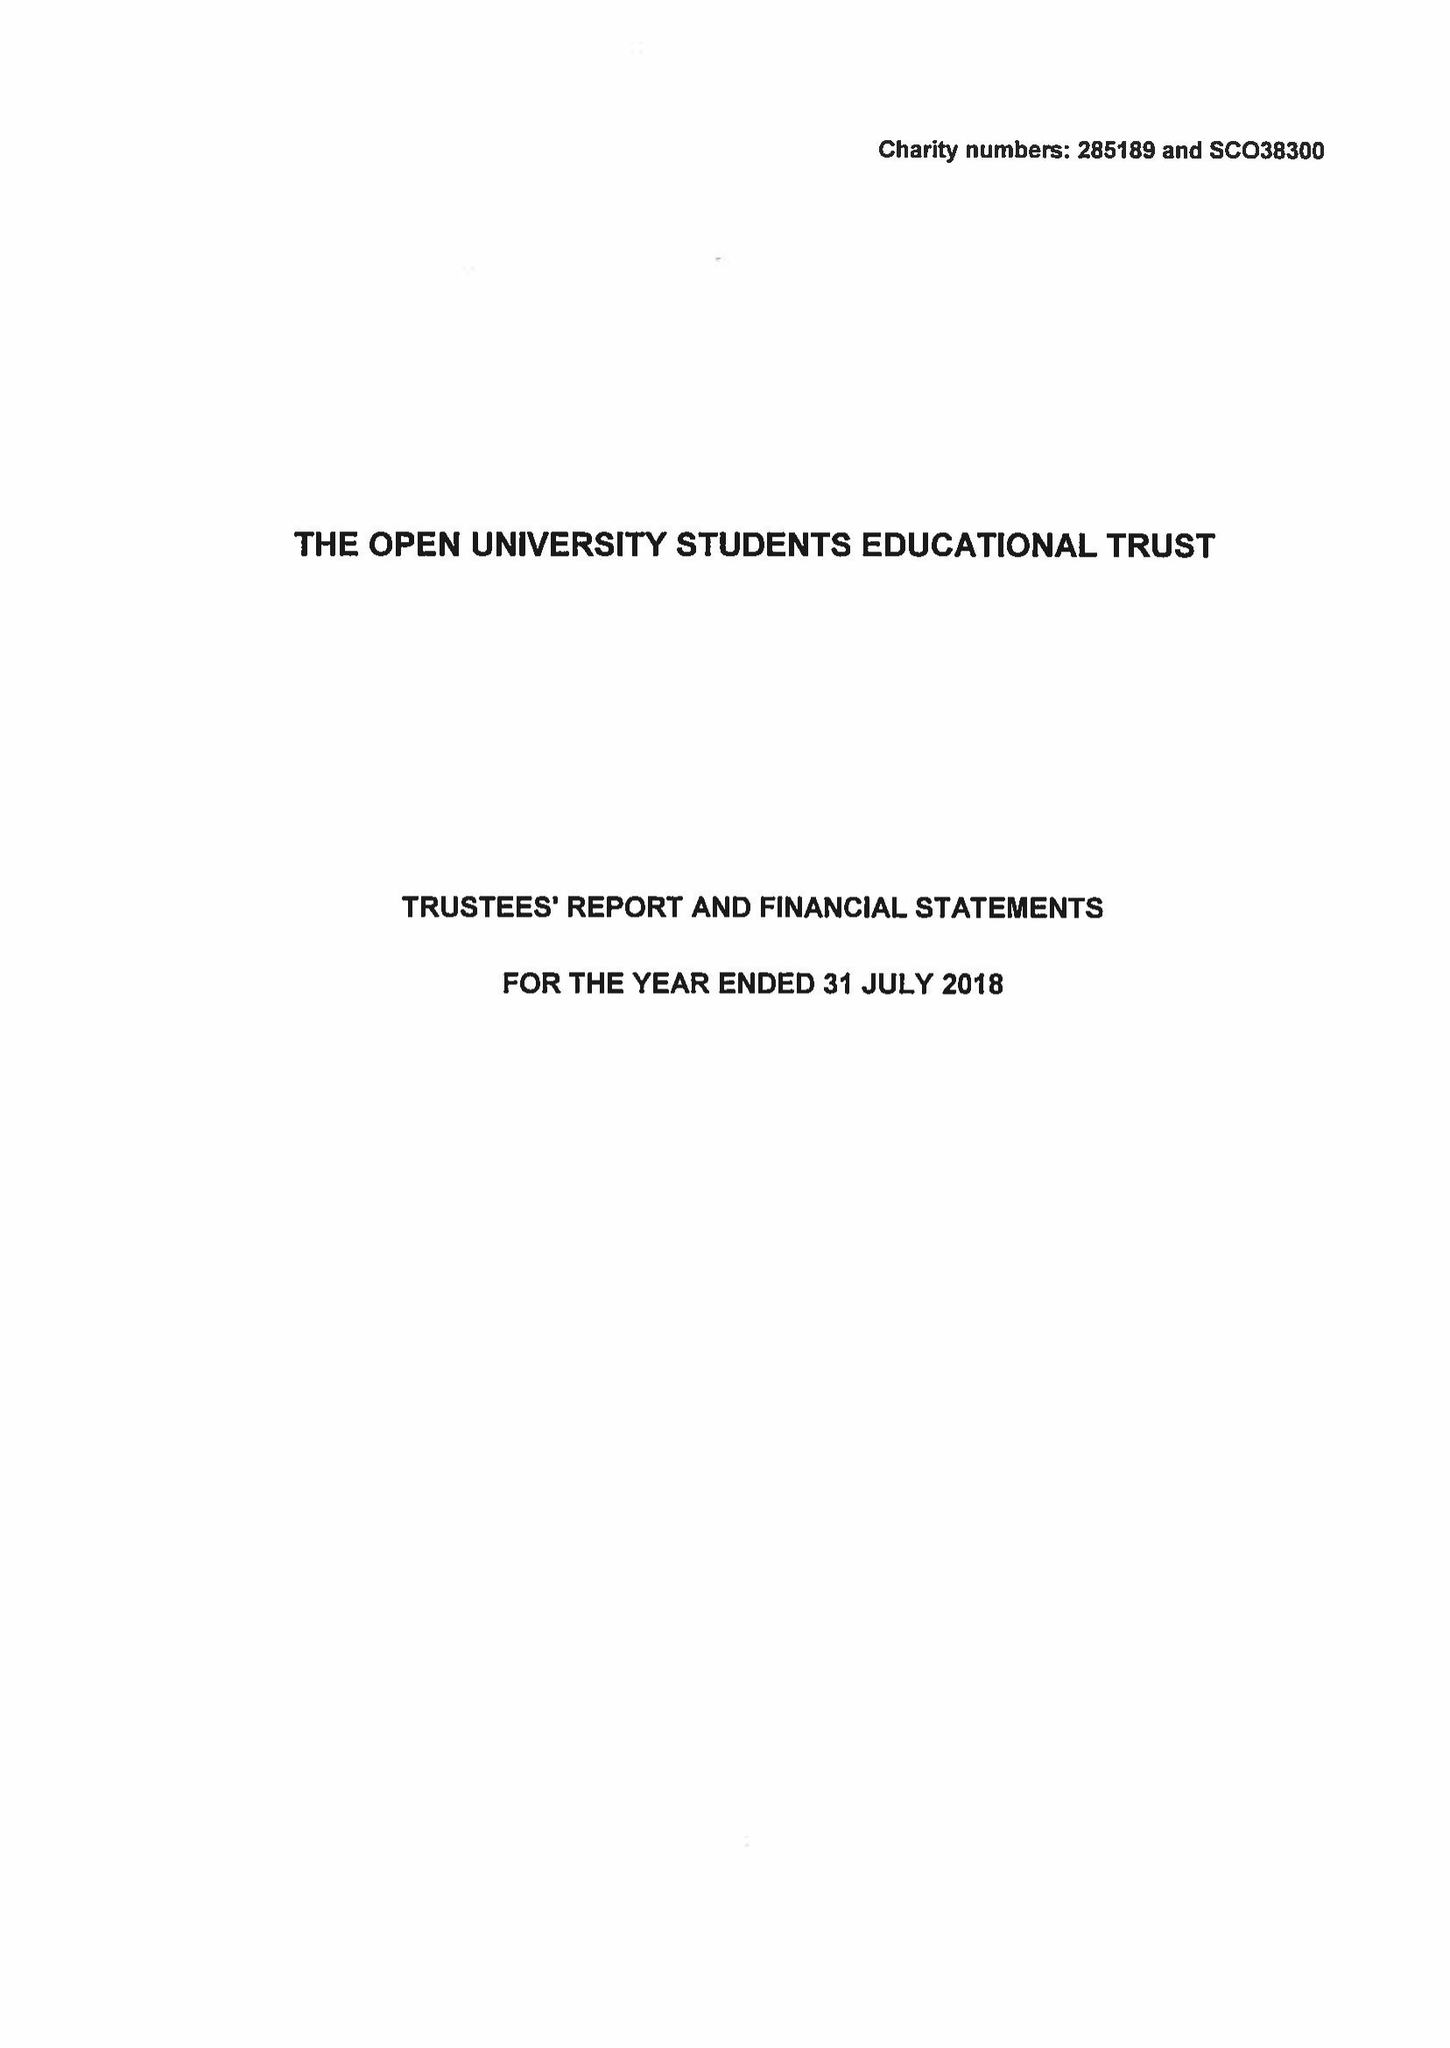What is the value for the address__post_town?
Answer the question using a single word or phrase. MILTON KEYNES 